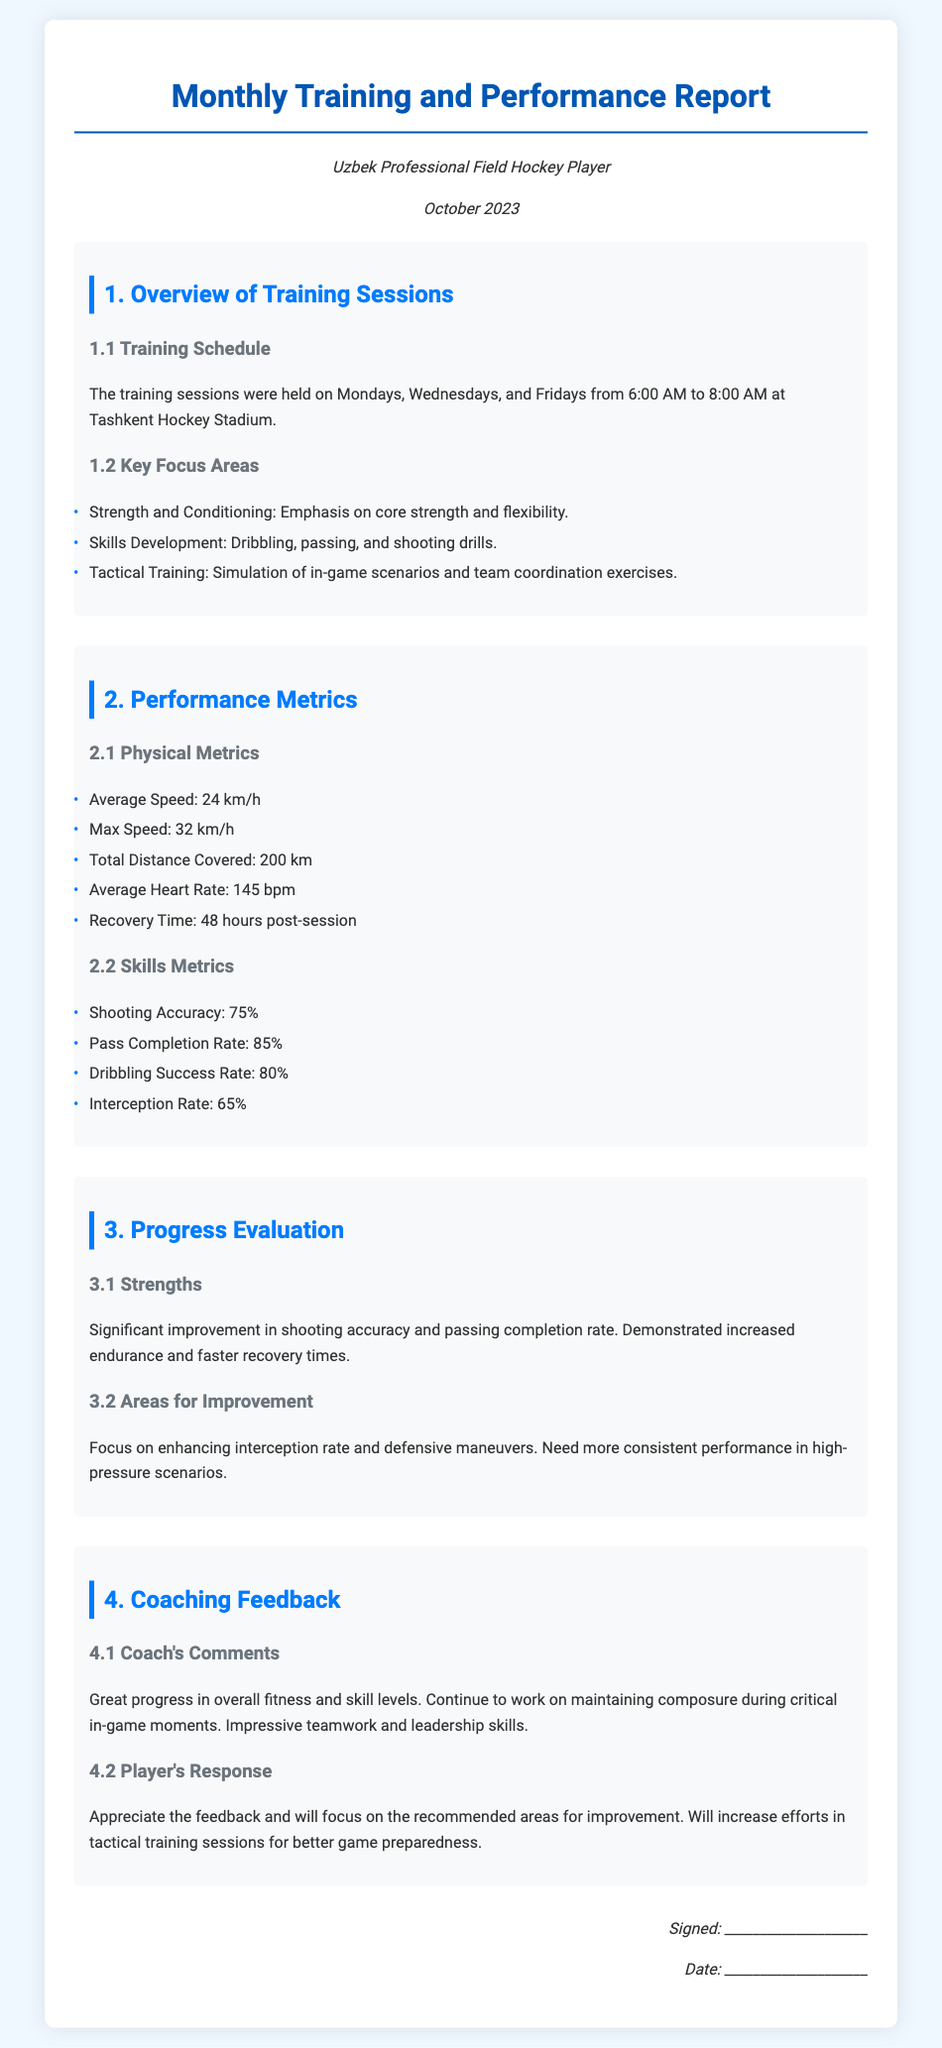what days were the training sessions held? The training sessions were held on Mondays, Wednesdays, and Fridays, as stated in the training schedule section.
Answer: Mondays, Wednesdays, and Fridays what is the average speed recorded? The document specifies the average speed measured during training sessions.
Answer: 24 km/h what was the shooting accuracy percentage? The shooting accuracy is provided under the Skills Metrics section.
Answer: 75% what are the strengths identified in the progress evaluation? The strengths are listed in the Progress Evaluation section, highlighting specific improvements.
Answer: Shooting accuracy and passing completion rate what feedback did the coach provide? The coach's comments are summarized in the Coaching Feedback section of the document.
Answer: Great progress in overall fitness and skill levels what area needs improvement according to the report? The report identifies several areas for improvement in the Progress Evaluation section.
Answer: Interception rate and defensive maneuvers when was this report generated? The document mentions the specific date in the meta-info section.
Answer: October 2023 what was the maximum speed recorded? The maximum speed is mentioned in the Performance Metrics section of the report.
Answer: 32 km/h what is the average heart rate during the training? The average heart rate is listed under Physical Metrics in the Performance Metrics section.
Answer: 145 bpm 